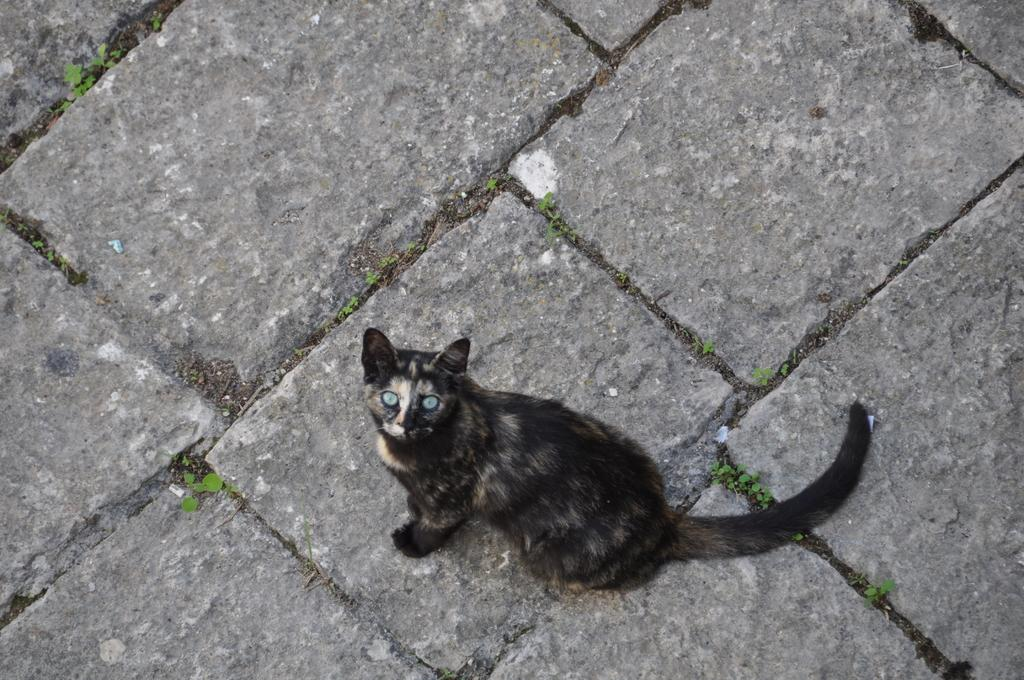What type of animal is in the image? There is a cat in the image. Where is the cat located in the image? The cat is on the ground. What type of surface is the cat on? There is grass visible on the ground in the image. What type of pipe can be seen in the image? There is no pipe present in the image; it features a cat on the grassy ground. What is the chance of the cat leading the group in the image? There is no group or leadership role mentioned in the image, as it only shows a cat on the grassy ground. 